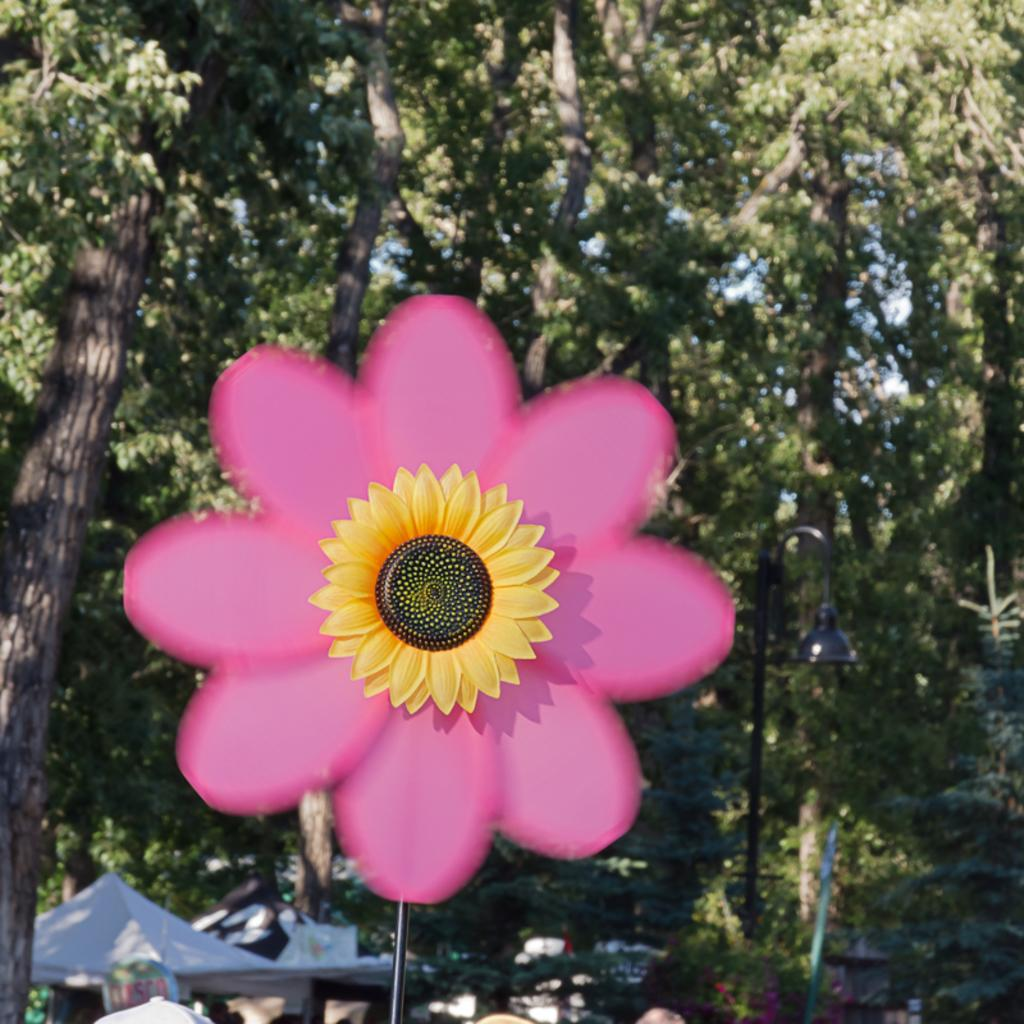What type of flowers are in the image? There is a sunflower on a pink flower in the image. What is behind the flowers? There is a stand behind the flowers. What structures are visible at the bottom of the image? Tents, poles, and a light pole are visible at the bottom of the image. What can be seen in the background of the image? There are trees in the background of the image. How many boats are tied to the light pole in the image? There are no boats present in the image, so it is not possible to determine how many are tied to the light pole. 